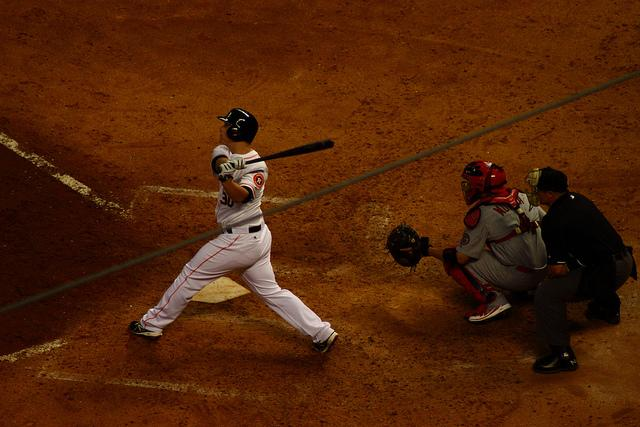What are the team colors for the team playing at pitch? Please explain your reasoning. red. The colors appear to be a and gray. it's hard to tell. 